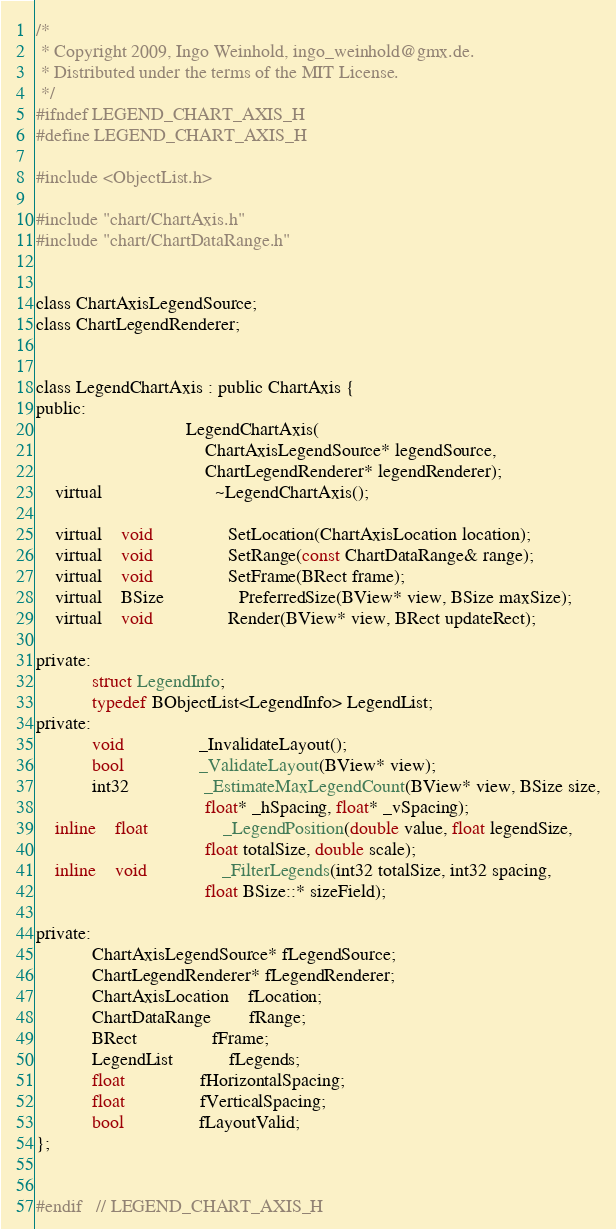Convert code to text. <code><loc_0><loc_0><loc_500><loc_500><_C_>/*
 * Copyright 2009, Ingo Weinhold, ingo_weinhold@gmx.de.
 * Distributed under the terms of the MIT License.
 */
#ifndef LEGEND_CHART_AXIS_H
#define LEGEND_CHART_AXIS_H

#include <ObjectList.h>

#include "chart/ChartAxis.h"
#include "chart/ChartDataRange.h"


class ChartAxisLegendSource;
class ChartLegendRenderer;


class LegendChartAxis : public ChartAxis {
public:
								LegendChartAxis(
									ChartAxisLegendSource* legendSource,
									ChartLegendRenderer* legendRenderer);
	virtual						~LegendChartAxis();

	virtual	void				SetLocation(ChartAxisLocation location);
	virtual	void				SetRange(const ChartDataRange& range);
	virtual	void				SetFrame(BRect frame);
	virtual	BSize				PreferredSize(BView* view, BSize maxSize);
	virtual	void				Render(BView* view, BRect updateRect);

private:
			struct LegendInfo;
			typedef BObjectList<LegendInfo> LegendList;
private:
			void				_InvalidateLayout();
			bool				_ValidateLayout(BView* view);
			int32				_EstimateMaxLegendCount(BView* view, BSize size,
									float* _hSpacing, float* _vSpacing);
	inline	float				_LegendPosition(double value, float legendSize,
									float totalSize, double scale);
	inline	void				_FilterLegends(int32 totalSize, int32 spacing,
									float BSize::* sizeField);

private:
			ChartAxisLegendSource* fLegendSource;
			ChartLegendRenderer* fLegendRenderer;
			ChartAxisLocation	fLocation;
			ChartDataRange		fRange;
			BRect				fFrame;
			LegendList			fLegends;
			float				fHorizontalSpacing;
			float				fVerticalSpacing;
			bool				fLayoutValid;
};


#endif	// LEGEND_CHART_AXIS_H
</code> 